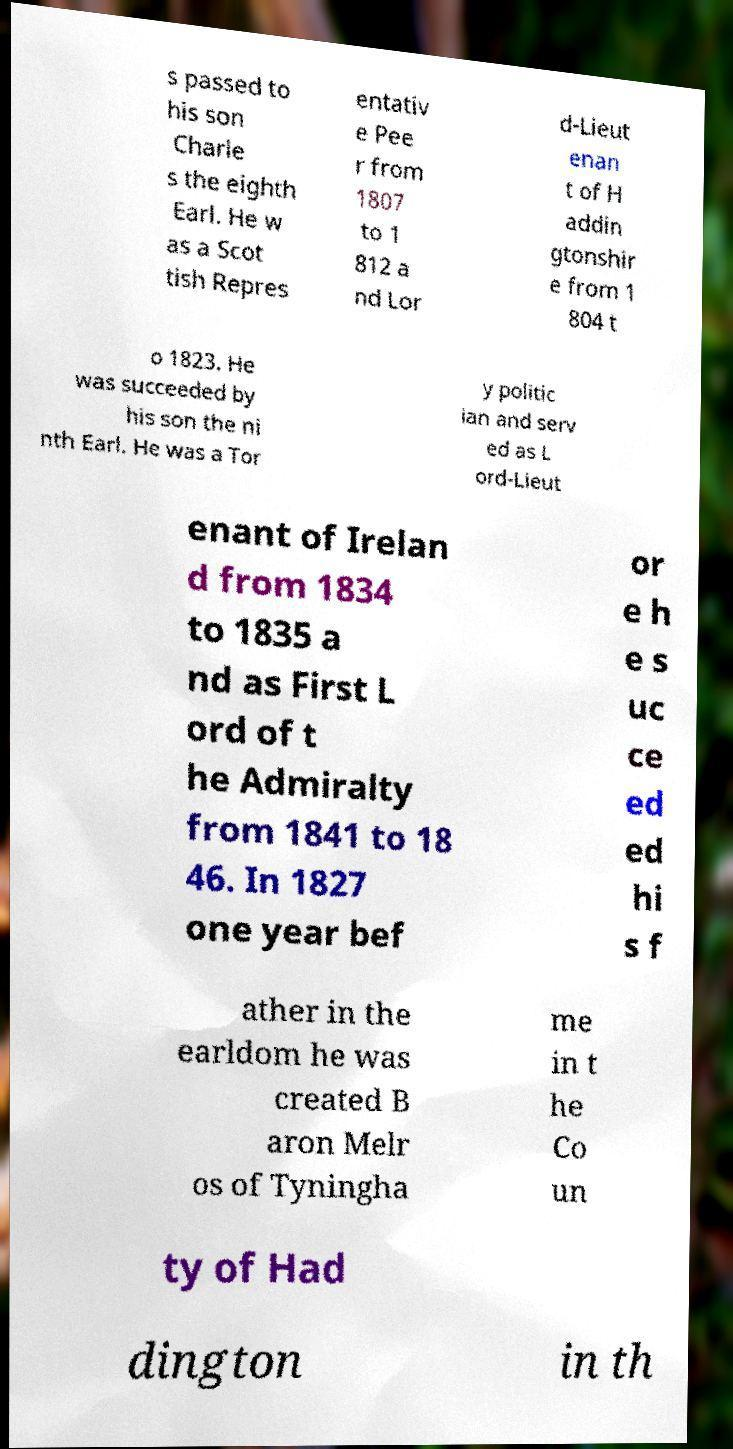What messages or text are displayed in this image? I need them in a readable, typed format. s passed to his son Charle s the eighth Earl. He w as a Scot tish Repres entativ e Pee r from 1807 to 1 812 a nd Lor d-Lieut enan t of H addin gtonshir e from 1 804 t o 1823. He was succeeded by his son the ni nth Earl. He was a Tor y politic ian and serv ed as L ord-Lieut enant of Irelan d from 1834 to 1835 a nd as First L ord of t he Admiralty from 1841 to 18 46. In 1827 one year bef or e h e s uc ce ed ed hi s f ather in the earldom he was created B aron Melr os of Tyningha me in t he Co un ty of Had dington in th 